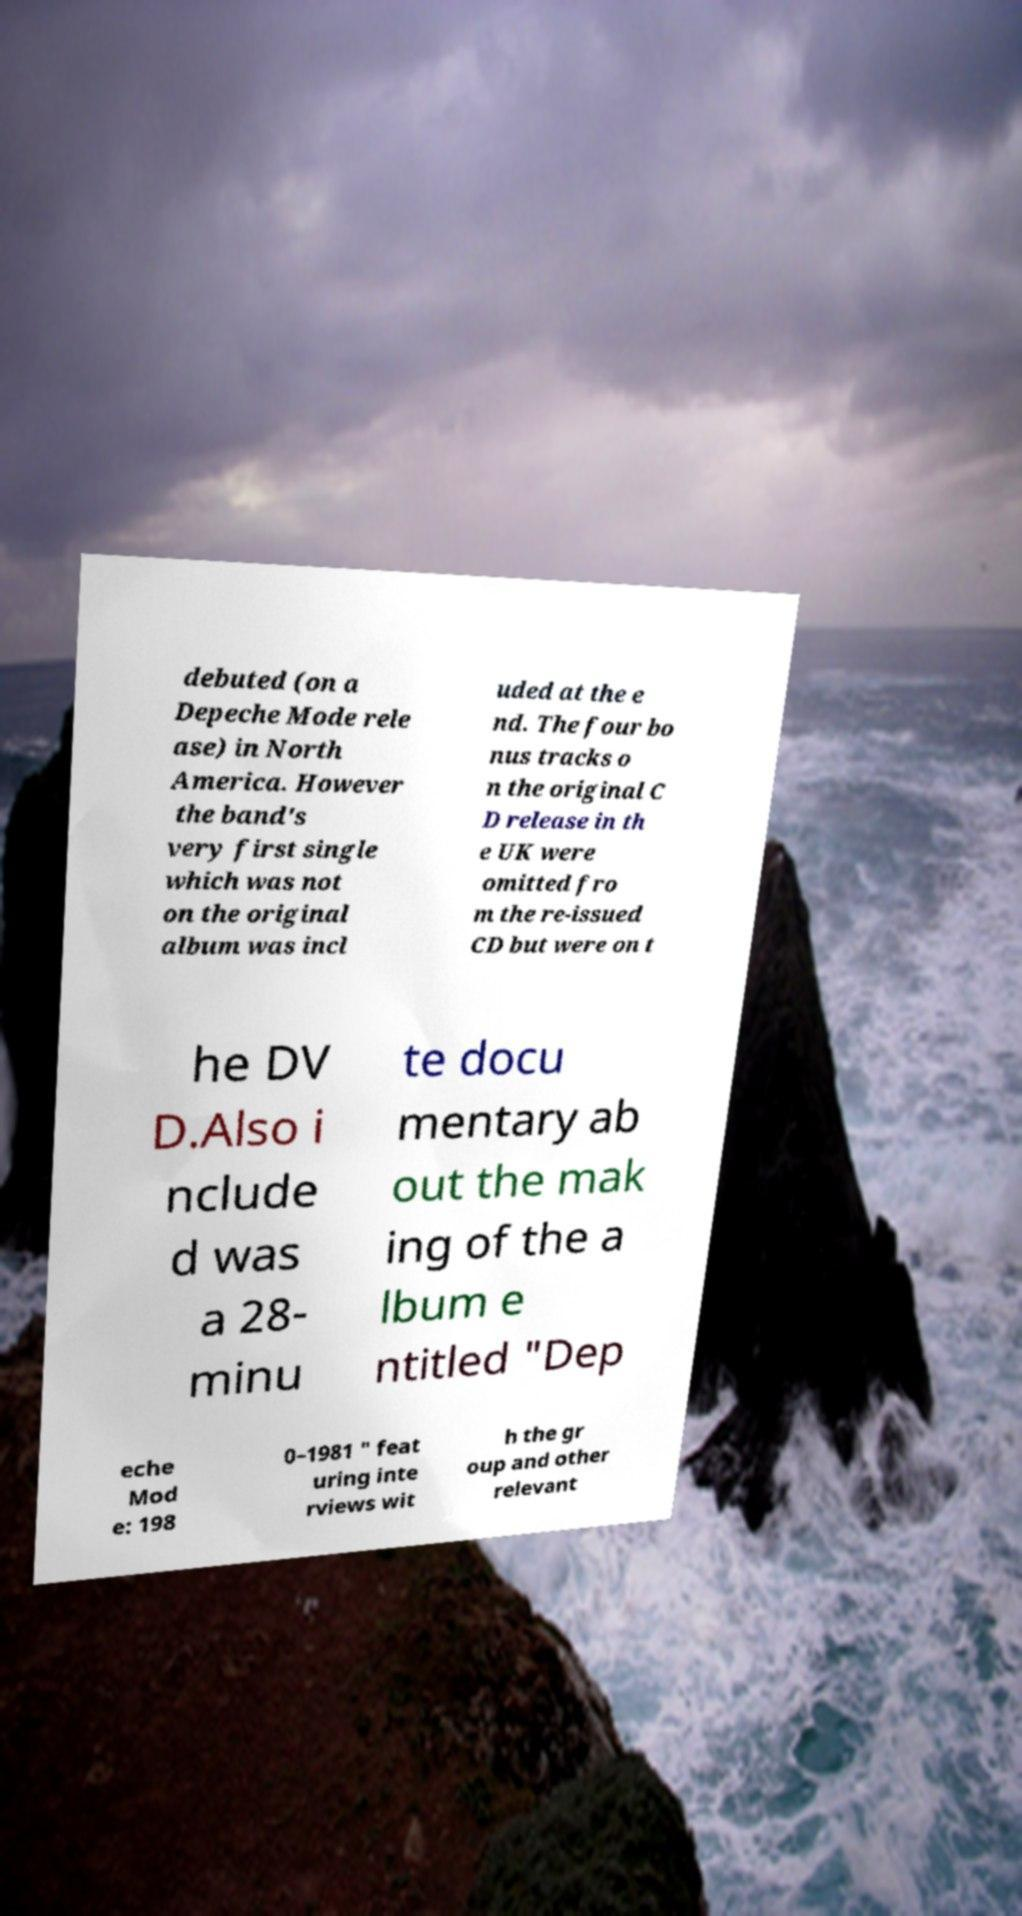Can you read and provide the text displayed in the image?This photo seems to have some interesting text. Can you extract and type it out for me? debuted (on a Depeche Mode rele ase) in North America. However the band's very first single which was not on the original album was incl uded at the e nd. The four bo nus tracks o n the original C D release in th e UK were omitted fro m the re-issued CD but were on t he DV D.Also i nclude d was a 28- minu te docu mentary ab out the mak ing of the a lbum e ntitled "Dep eche Mod e: 198 0–1981 " feat uring inte rviews wit h the gr oup and other relevant 